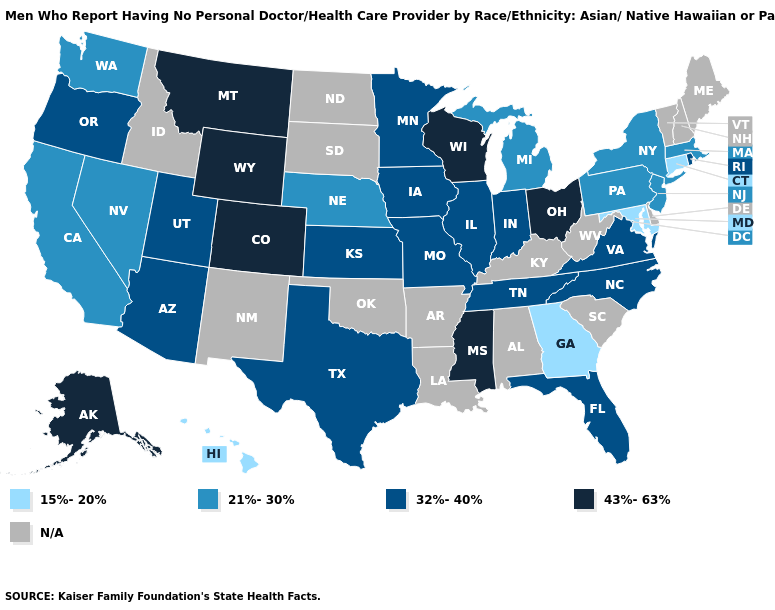Which states hav the highest value in the West?
Write a very short answer. Alaska, Colorado, Montana, Wyoming. Name the states that have a value in the range 43%-63%?
Be succinct. Alaska, Colorado, Mississippi, Montana, Ohio, Wisconsin, Wyoming. Does Hawaii have the lowest value in the West?
Concise answer only. Yes. Which states have the highest value in the USA?
Keep it brief. Alaska, Colorado, Mississippi, Montana, Ohio, Wisconsin, Wyoming. What is the value of Iowa?
Quick response, please. 32%-40%. What is the value of Iowa?
Concise answer only. 32%-40%. What is the value of Maryland?
Answer briefly. 15%-20%. Which states have the highest value in the USA?
Keep it brief. Alaska, Colorado, Mississippi, Montana, Ohio, Wisconsin, Wyoming. What is the lowest value in states that border Montana?
Give a very brief answer. 43%-63%. Does Minnesota have the lowest value in the MidWest?
Quick response, please. No. What is the value of North Dakota?
Concise answer only. N/A. Name the states that have a value in the range 32%-40%?
Give a very brief answer. Arizona, Florida, Illinois, Indiana, Iowa, Kansas, Minnesota, Missouri, North Carolina, Oregon, Rhode Island, Tennessee, Texas, Utah, Virginia. What is the value of West Virginia?
Be succinct. N/A. 